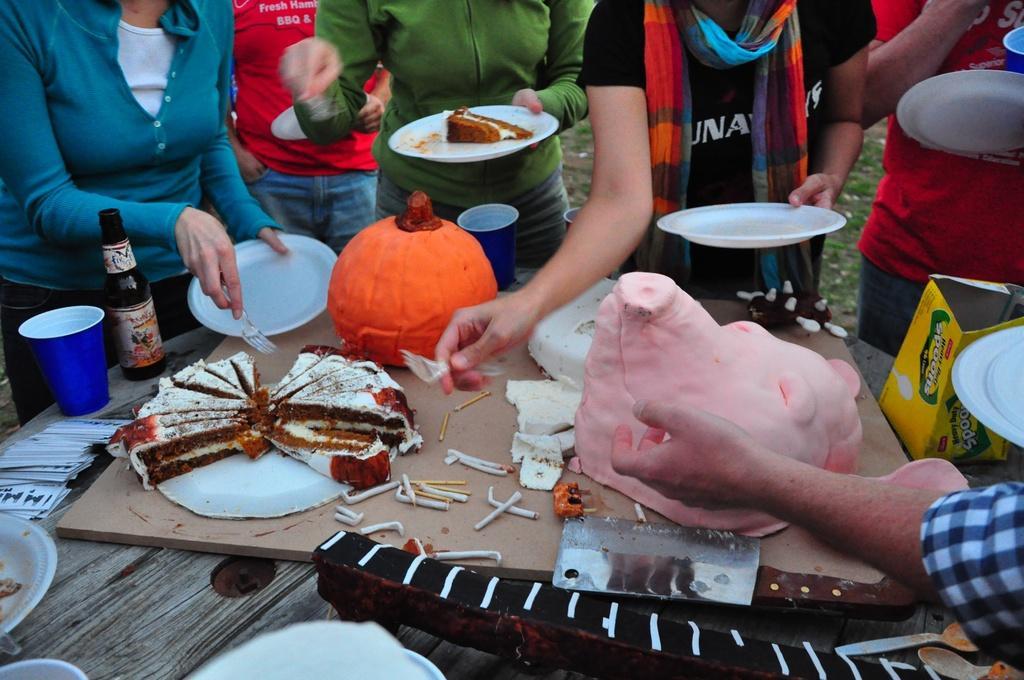How would you summarize this image in a sentence or two? In the center of the image we can see some food placed on the table. We can also see a knife, a bottle, glass, some cards, some spoons and a cardboard box placed beside them. In the background we can see a group of people holding the plates. We can also see some grass. 